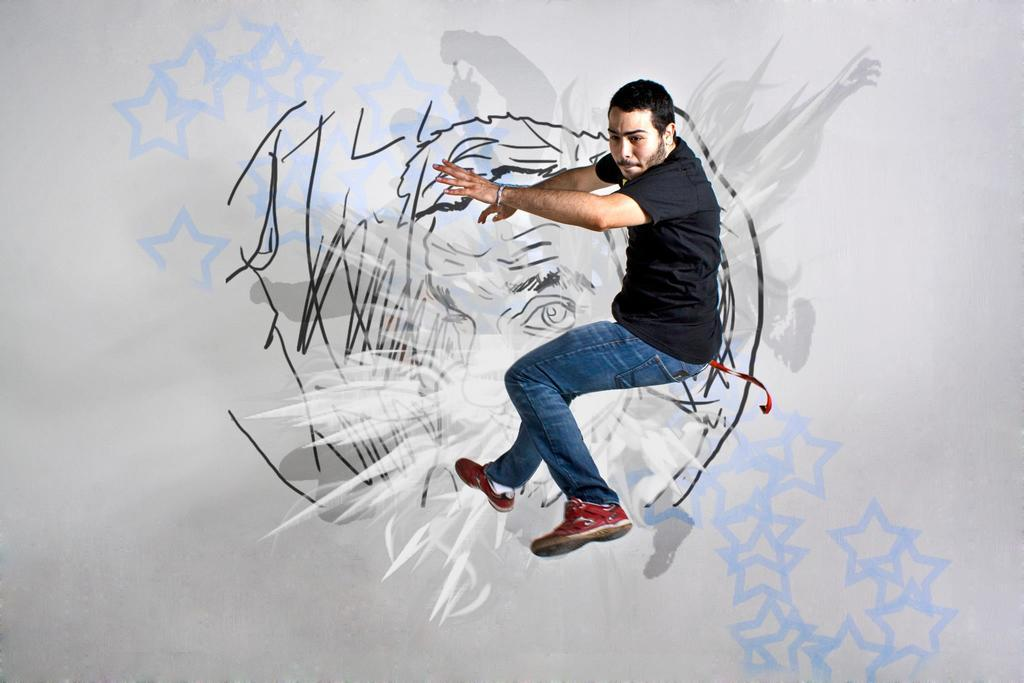Who is present in the image? There is a man in the image. What is the man doing in the image? The man appears to be in motion. What can be seen in the background of the image? There is a drawing in the background of the image. What color is the drawing in the image? The drawing is white in color. Where is the zebra located in the image? There is no zebra present in the image. What does the man need to complete his task in the image? The provided facts do not mention any specific task the man is performing or any items he might need to complete it. 